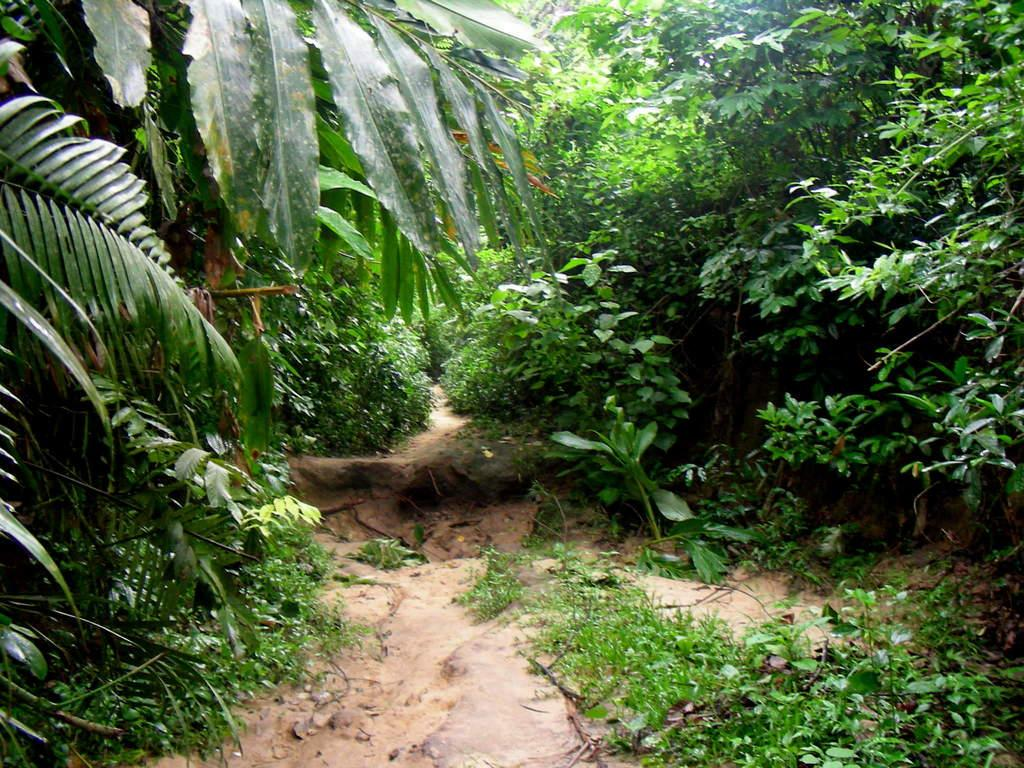What type of vegetation can be seen in the image? There are plants, grass, and trees in the image. What is the surface on which the vegetation is growing? The ground is visible in the image. What type of paste is being used to hold the trees together in the image? There is no paste present in the image, and the trees are not being held together. 